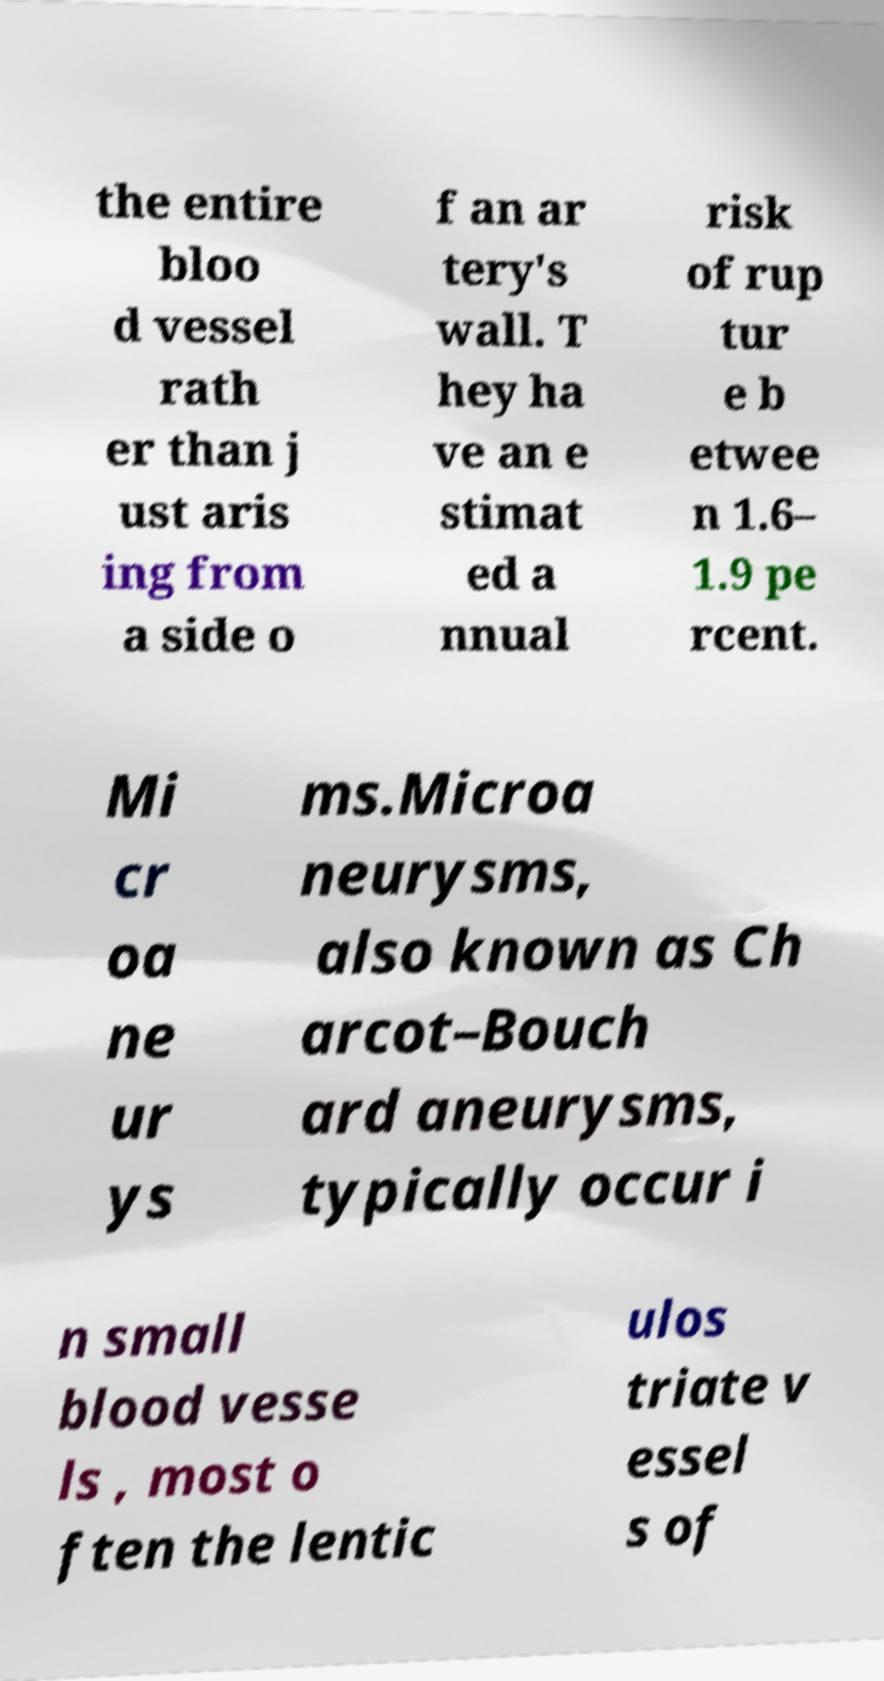Could you extract and type out the text from this image? the entire bloo d vessel rath er than j ust aris ing from a side o f an ar tery's wall. T hey ha ve an e stimat ed a nnual risk of rup tur e b etwee n 1.6– 1.9 pe rcent. Mi cr oa ne ur ys ms.Microa neurysms, also known as Ch arcot–Bouch ard aneurysms, typically occur i n small blood vesse ls , most o ften the lentic ulos triate v essel s of 